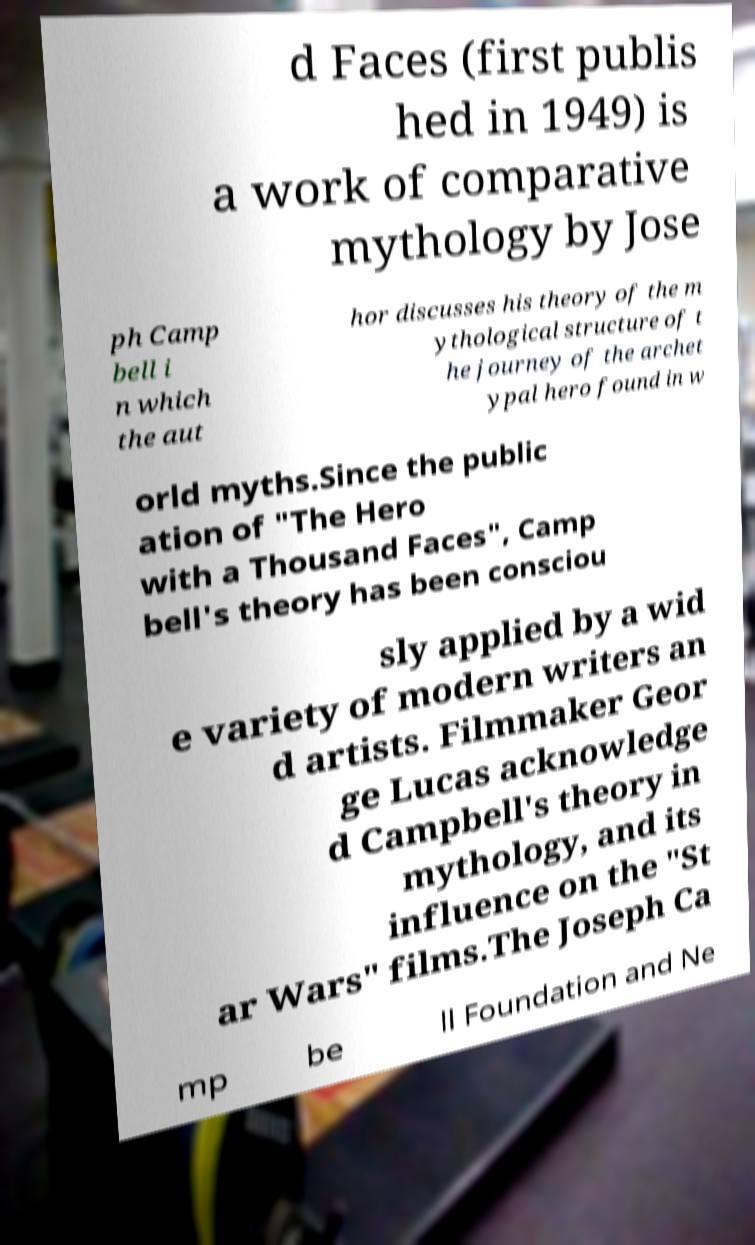Please read and relay the text visible in this image. What does it say? d Faces (first publis hed in 1949) is a work of comparative mythology by Jose ph Camp bell i n which the aut hor discusses his theory of the m ythological structure of t he journey of the archet ypal hero found in w orld myths.Since the public ation of "The Hero with a Thousand Faces", Camp bell's theory has been consciou sly applied by a wid e variety of modern writers an d artists. Filmmaker Geor ge Lucas acknowledge d Campbell's theory in mythology, and its influence on the "St ar Wars" films.The Joseph Ca mp be ll Foundation and Ne 